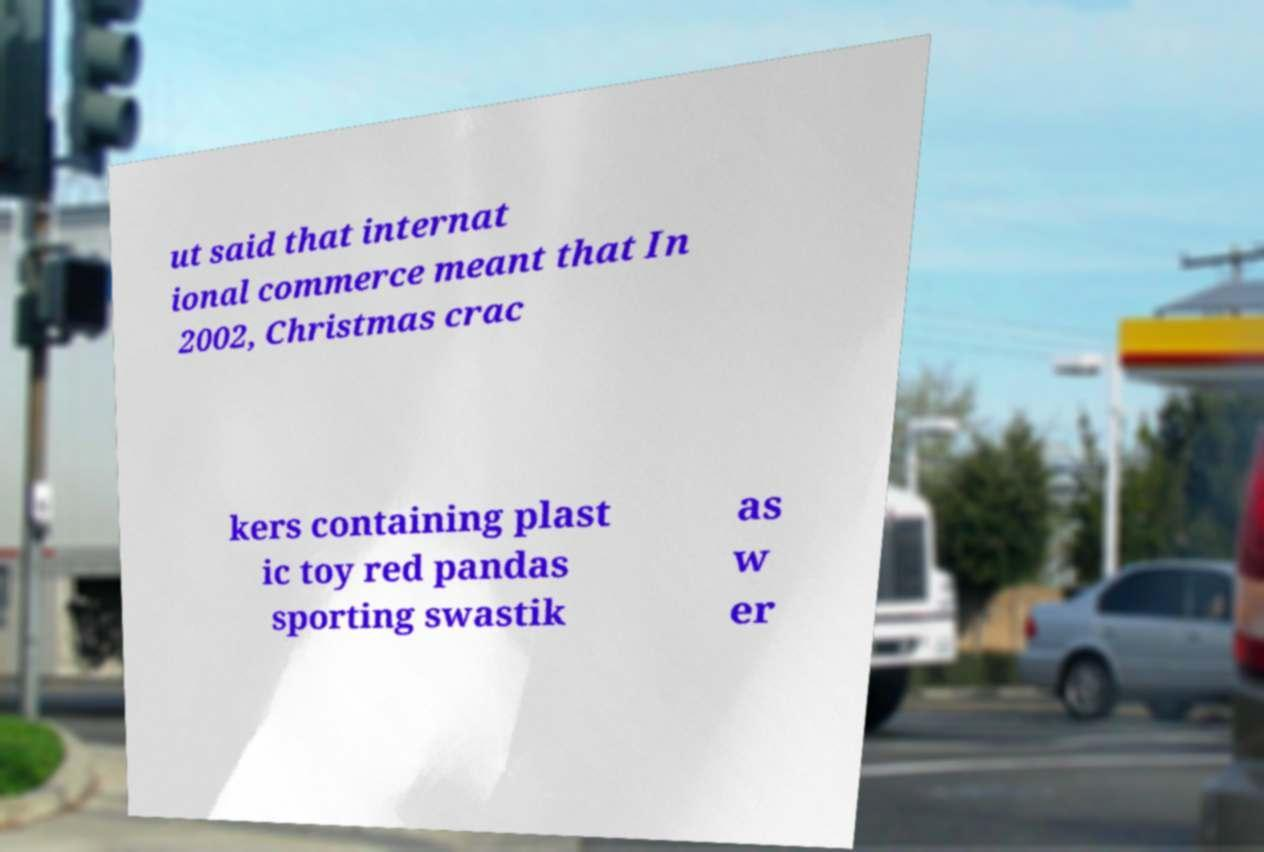What messages or text are displayed in this image? I need them in a readable, typed format. ut said that internat ional commerce meant that In 2002, Christmas crac kers containing plast ic toy red pandas sporting swastik as w er 